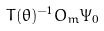<formula> <loc_0><loc_0><loc_500><loc_500>T ( \theta ) ^ { - 1 } O _ { m } \Psi _ { 0 }</formula> 